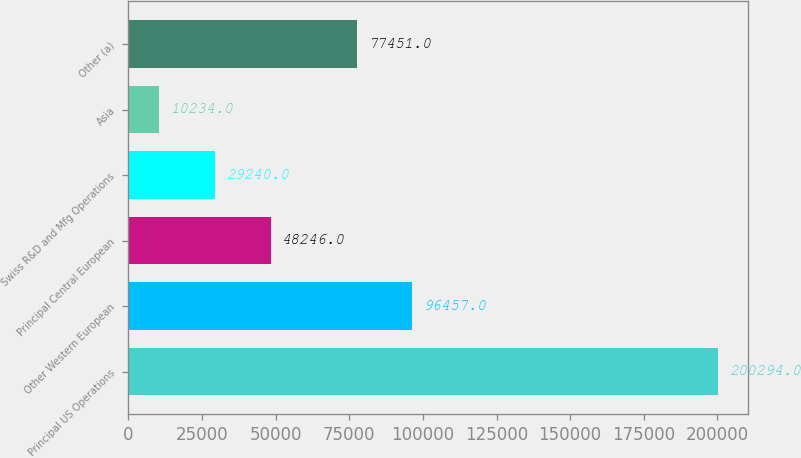Convert chart to OTSL. <chart><loc_0><loc_0><loc_500><loc_500><bar_chart><fcel>Principal US Operations<fcel>Other Western European<fcel>Principal Central European<fcel>Swiss R&D and Mfg Operations<fcel>Asia<fcel>Other (a)<nl><fcel>200294<fcel>96457<fcel>48246<fcel>29240<fcel>10234<fcel>77451<nl></chart> 